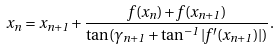<formula> <loc_0><loc_0><loc_500><loc_500>x _ { n } = x _ { n + 1 } + \frac { f ( x _ { n } ) + f ( x _ { n + 1 } ) } { \tan ( \gamma _ { n + 1 } + \tan ^ { - 1 } | f ^ { \prime } ( x _ { n + 1 } ) | ) } .</formula> 